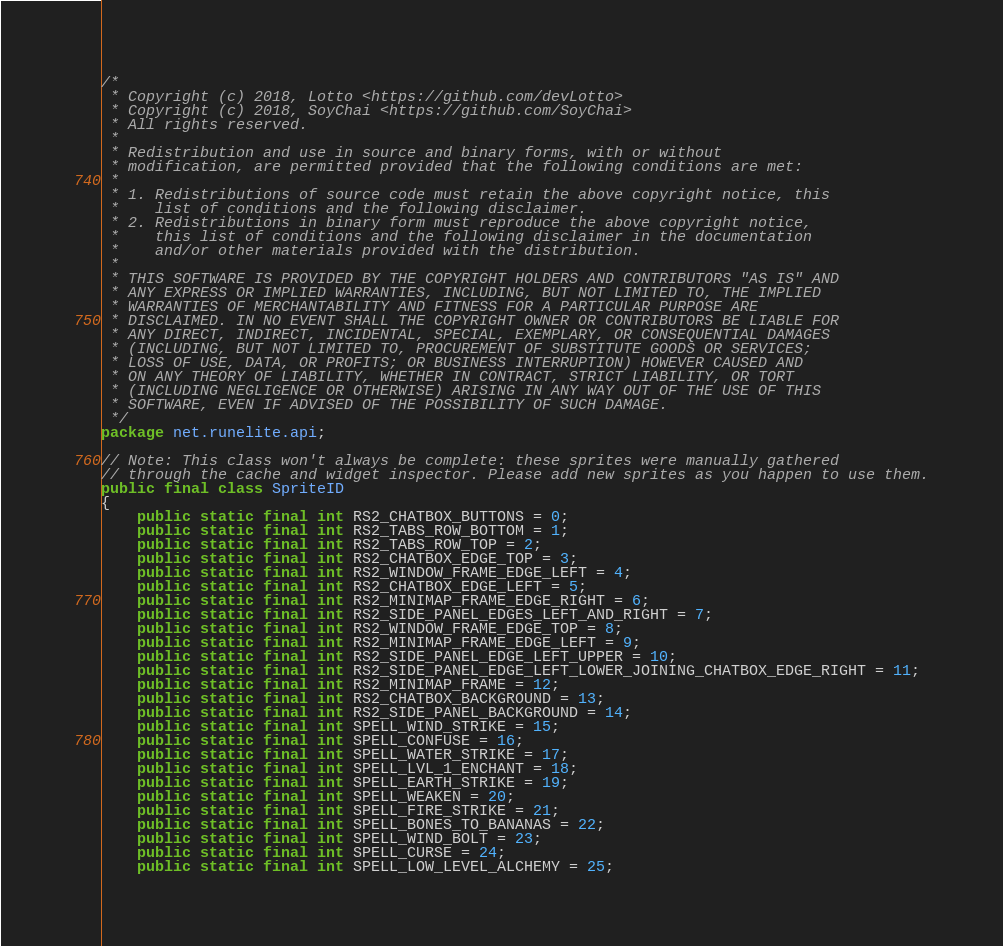Convert code to text. <code><loc_0><loc_0><loc_500><loc_500><_Java_>/*
 * Copyright (c) 2018, Lotto <https://github.com/devLotto>
 * Copyright (c) 2018, SoyChai <https://github.com/SoyChai>
 * All rights reserved.
 *
 * Redistribution and use in source and binary forms, with or without
 * modification, are permitted provided that the following conditions are met:
 *
 * 1. Redistributions of source code must retain the above copyright notice, this
 *    list of conditions and the following disclaimer.
 * 2. Redistributions in binary form must reproduce the above copyright notice,
 *    this list of conditions and the following disclaimer in the documentation
 *    and/or other materials provided with the distribution.
 *
 * THIS SOFTWARE IS PROVIDED BY THE COPYRIGHT HOLDERS AND CONTRIBUTORS "AS IS" AND
 * ANY EXPRESS OR IMPLIED WARRANTIES, INCLUDING, BUT NOT LIMITED TO, THE IMPLIED
 * WARRANTIES OF MERCHANTABILITY AND FITNESS FOR A PARTICULAR PURPOSE ARE
 * DISCLAIMED. IN NO EVENT SHALL THE COPYRIGHT OWNER OR CONTRIBUTORS BE LIABLE FOR
 * ANY DIRECT, INDIRECT, INCIDENTAL, SPECIAL, EXEMPLARY, OR CONSEQUENTIAL DAMAGES
 * (INCLUDING, BUT NOT LIMITED TO, PROCUREMENT OF SUBSTITUTE GOODS OR SERVICES;
 * LOSS OF USE, DATA, OR PROFITS; OR BUSINESS INTERRUPTION) HOWEVER CAUSED AND
 * ON ANY THEORY OF LIABILITY, WHETHER IN CONTRACT, STRICT LIABILITY, OR TORT
 * (INCLUDING NEGLIGENCE OR OTHERWISE) ARISING IN ANY WAY OUT OF THE USE OF THIS
 * SOFTWARE, EVEN IF ADVISED OF THE POSSIBILITY OF SUCH DAMAGE.
 */
package net.runelite.api;

// Note: This class won't always be complete: these sprites were manually gathered
// through the cache and widget inspector. Please add new sprites as you happen to use them.
public final class SpriteID
{
	public static final int RS2_CHATBOX_BUTTONS = 0;
	public static final int RS2_TABS_ROW_BOTTOM = 1;
	public static final int RS2_TABS_ROW_TOP = 2;
	public static final int RS2_CHATBOX_EDGE_TOP = 3;
	public static final int RS2_WINDOW_FRAME_EDGE_LEFT = 4;
	public static final int RS2_CHATBOX_EDGE_LEFT = 5;
	public static final int RS2_MINIMAP_FRAME_EDGE_RIGHT = 6;
	public static final int RS2_SIDE_PANEL_EDGES_LEFT_AND_RIGHT = 7;
	public static final int RS2_WINDOW_FRAME_EDGE_TOP = 8;
	public static final int RS2_MINIMAP_FRAME_EDGE_LEFT = 9;
	public static final int RS2_SIDE_PANEL_EDGE_LEFT_UPPER = 10;
	public static final int RS2_SIDE_PANEL_EDGE_LEFT_LOWER_JOINING_CHATBOX_EDGE_RIGHT = 11;
	public static final int RS2_MINIMAP_FRAME = 12;
	public static final int RS2_CHATBOX_BACKGROUND = 13;
	public static final int RS2_SIDE_PANEL_BACKGROUND = 14;
	public static final int SPELL_WIND_STRIKE = 15;
	public static final int SPELL_CONFUSE = 16;
	public static final int SPELL_WATER_STRIKE = 17;
	public static final int SPELL_LVL_1_ENCHANT = 18;
	public static final int SPELL_EARTH_STRIKE = 19;
	public static final int SPELL_WEAKEN = 20;
	public static final int SPELL_FIRE_STRIKE = 21;
	public static final int SPELL_BONES_TO_BANANAS = 22;
	public static final int SPELL_WIND_BOLT = 23;
	public static final int SPELL_CURSE = 24;
	public static final int SPELL_LOW_LEVEL_ALCHEMY = 25;</code> 